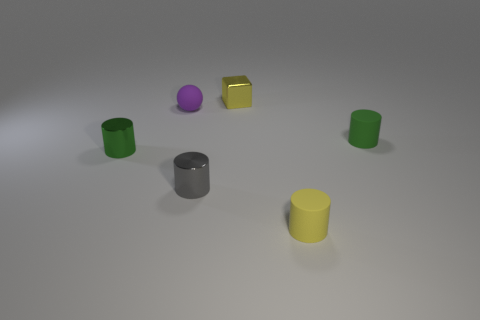Add 3 small red metallic spheres. How many objects exist? 9 Subtract all balls. How many objects are left? 5 Subtract all tiny objects. Subtract all big red cylinders. How many objects are left? 0 Add 6 metal objects. How many metal objects are left? 9 Add 2 rubber objects. How many rubber objects exist? 5 Subtract 0 yellow spheres. How many objects are left? 6 